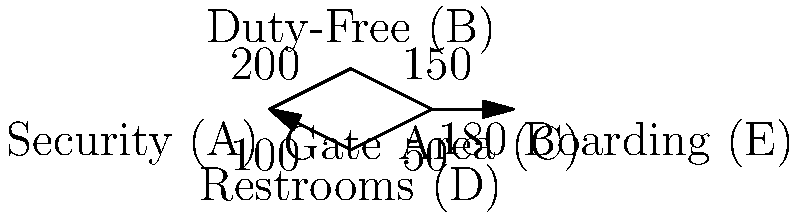As a travel agency manager, you're analyzing passenger flow through an airport terminal. The diagram shows different areas connected by paths, with the number of passengers moving between areas per hour. What is the maximum number of passengers that can reach the boarding area (E) per hour, assuming all passengers start at security (A)? To solve this problem, we need to find the maximum flow from node A (Security) to node E (Boarding). We'll use the concept of network flow and the max-flow min-cut theorem.

Step 1: Identify all possible paths from A to E:
1. A → B → C → E
2. A → D → C → E

Step 2: Calculate the flow capacity for each path:
1. A → B → C → E: min(200, 150, 180) = 150
2. A → D → C → E: min(100, 50, 180) = 50

Step 3: Sum up the flow capacities:
Total maximum flow = 150 + 50 = 200

Step 4: Verify the result using the max-flow min-cut theorem:
The minimum cut in this network is the cut that separates node C from node E, which has a capacity of 180.

Since our calculated maximum flow (200) is greater than the minimum cut capacity (180), we need to adjust our result.

Step 5: Adjust the result:
The maximum flow cannot exceed the capacity of the minimum cut, which is 180.

Therefore, the maximum number of passengers that can reach the boarding area (E) per hour is 180.
Answer: 180 passengers per hour 